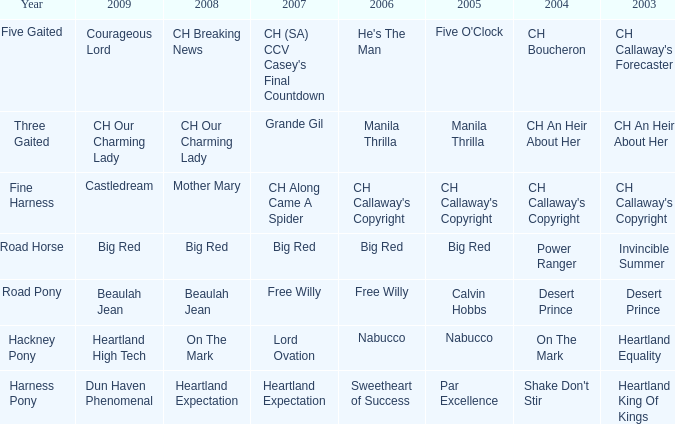What is the 2008 for 2009 heartland high tech? On The Mark. 